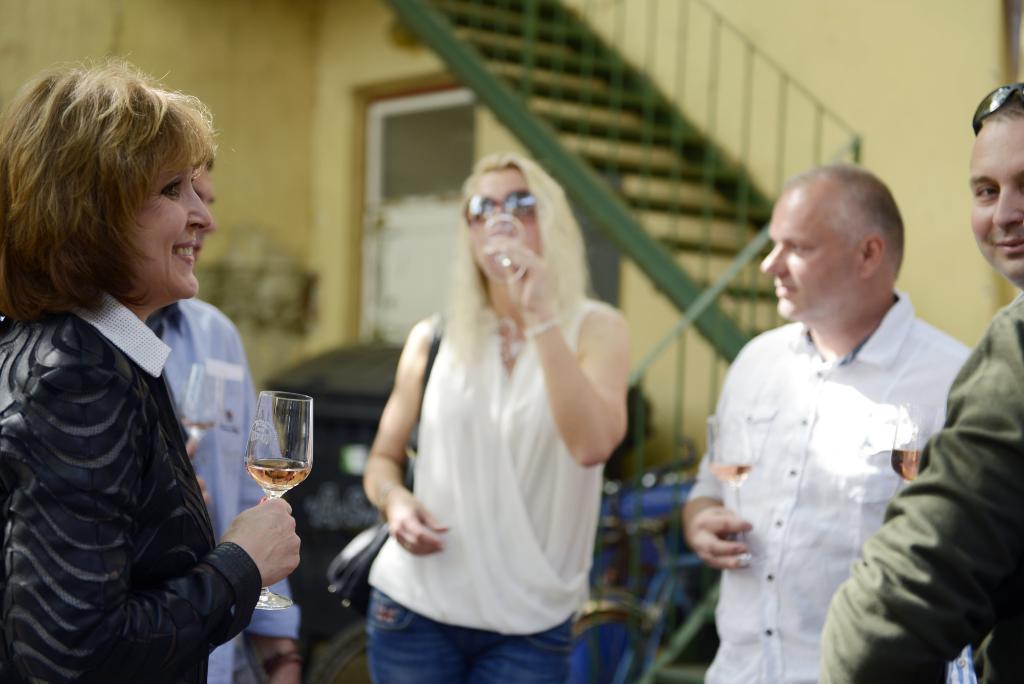In one or two sentences, can you explain what this image depicts? This picture contains five people and all of them are holding glasses containing cool drink in their hand. All of them are smiling. Behind them, we see a staircase in green color and beside that, we see a yellow color wall and a white door. Behind them, we see bicycles parked. In the background, it is blurred. 